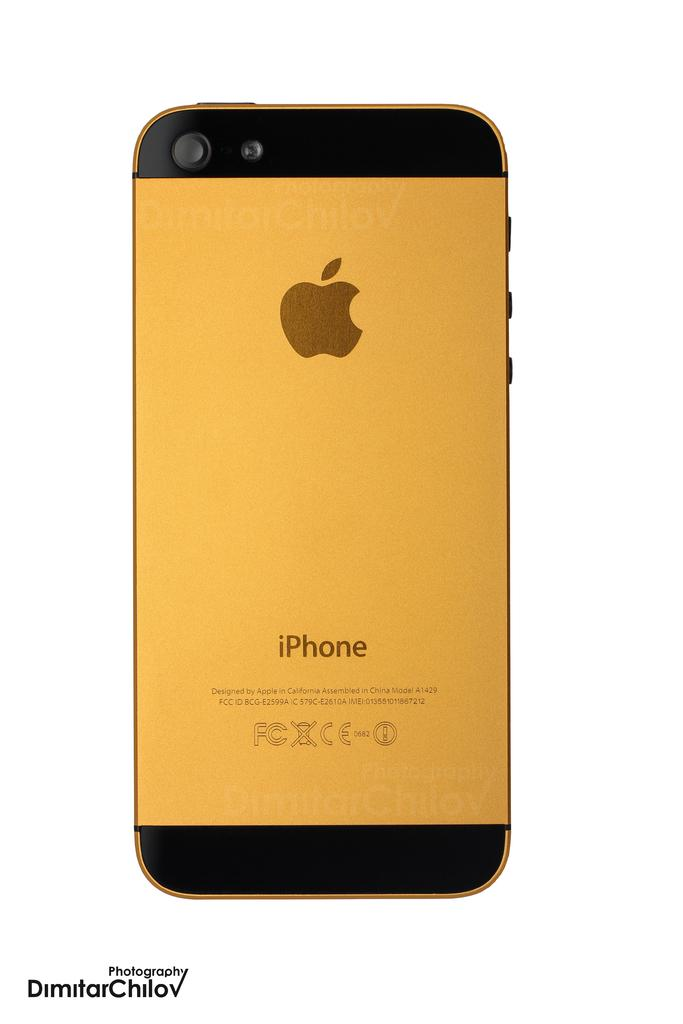<image>
Offer a succinct explanation of the picture presented. The back of a gold iPhone which says it was designed by Apple in California and assembled in China. 